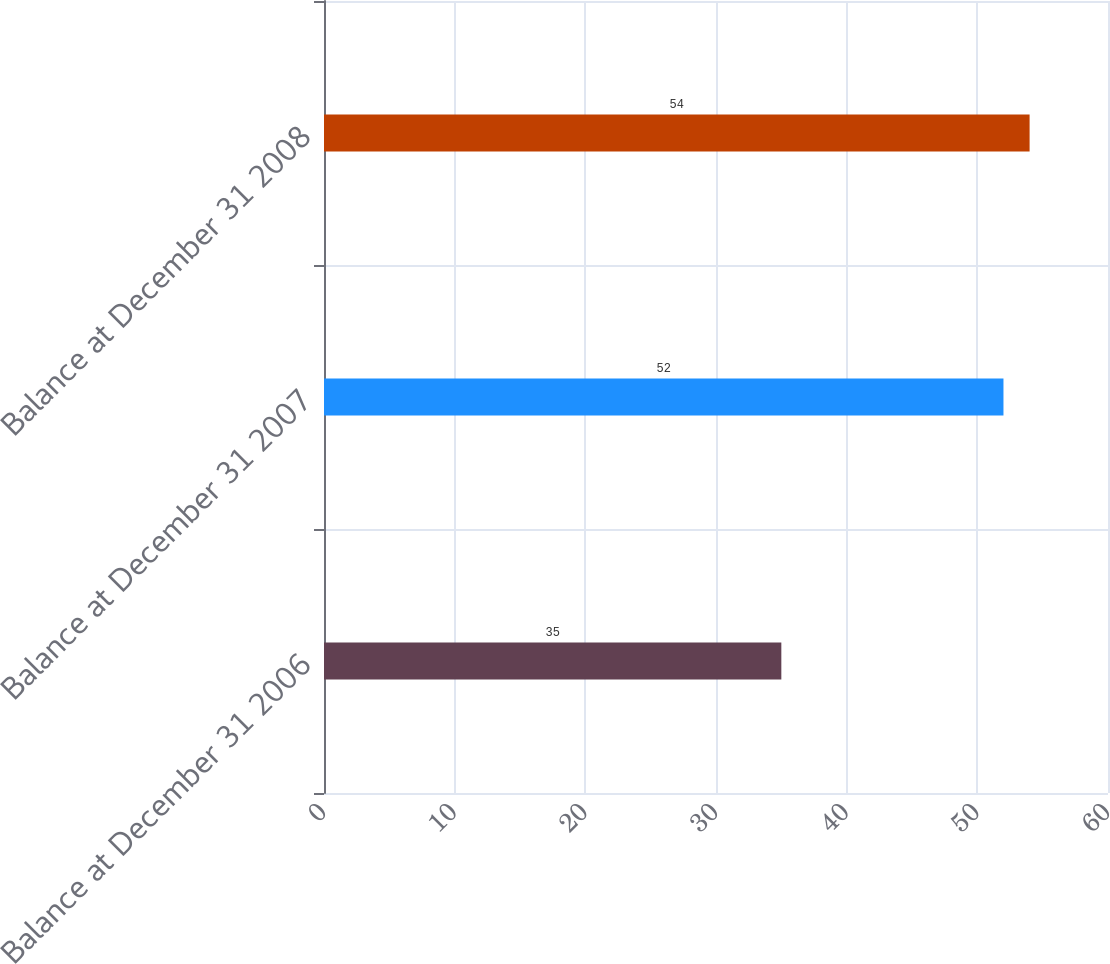Convert chart to OTSL. <chart><loc_0><loc_0><loc_500><loc_500><bar_chart><fcel>Balance at December 31 2006<fcel>Balance at December 31 2007<fcel>Balance at December 31 2008<nl><fcel>35<fcel>52<fcel>54<nl></chart> 